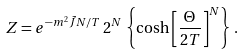Convert formula to latex. <formula><loc_0><loc_0><loc_500><loc_500>Z = e ^ { - m ^ { 2 } \tilde { J } N / T } \, 2 ^ { N } \, \left \{ \cosh \left [ \frac { \Theta } { 2 T } \right ] ^ { N } \right \} \, .</formula> 